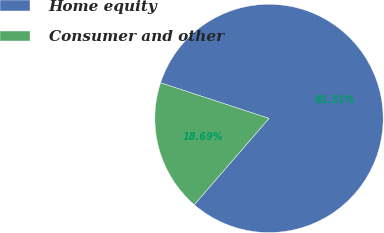Convert chart to OTSL. <chart><loc_0><loc_0><loc_500><loc_500><pie_chart><fcel>Home equity<fcel>Consumer and other<nl><fcel>81.31%<fcel>18.69%<nl></chart> 